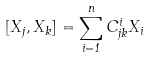<formula> <loc_0><loc_0><loc_500><loc_500>[ X _ { j } , X _ { k } ] = \sum _ { i = 1 } ^ { n } C _ { j k } ^ { i } X _ { i }</formula> 